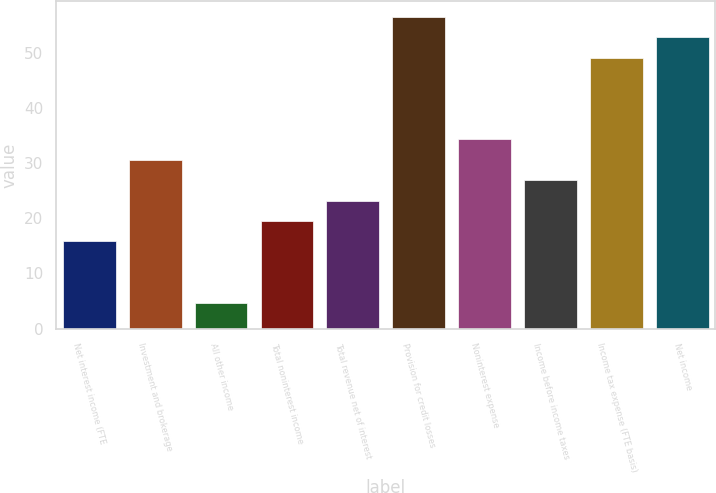Convert chart to OTSL. <chart><loc_0><loc_0><loc_500><loc_500><bar_chart><fcel>Net interest income (FTE<fcel>Investment and brokerage<fcel>All other income<fcel>Total noninterest income<fcel>Total revenue net of interest<fcel>Provision for credit losses<fcel>Noninterest expense<fcel>Income before income taxes<fcel>Income tax expense (FTE basis)<fcel>Net income<nl><fcel>15.8<fcel>30.6<fcel>4.7<fcel>19.5<fcel>23.2<fcel>56.5<fcel>34.3<fcel>26.9<fcel>49.1<fcel>52.8<nl></chart> 